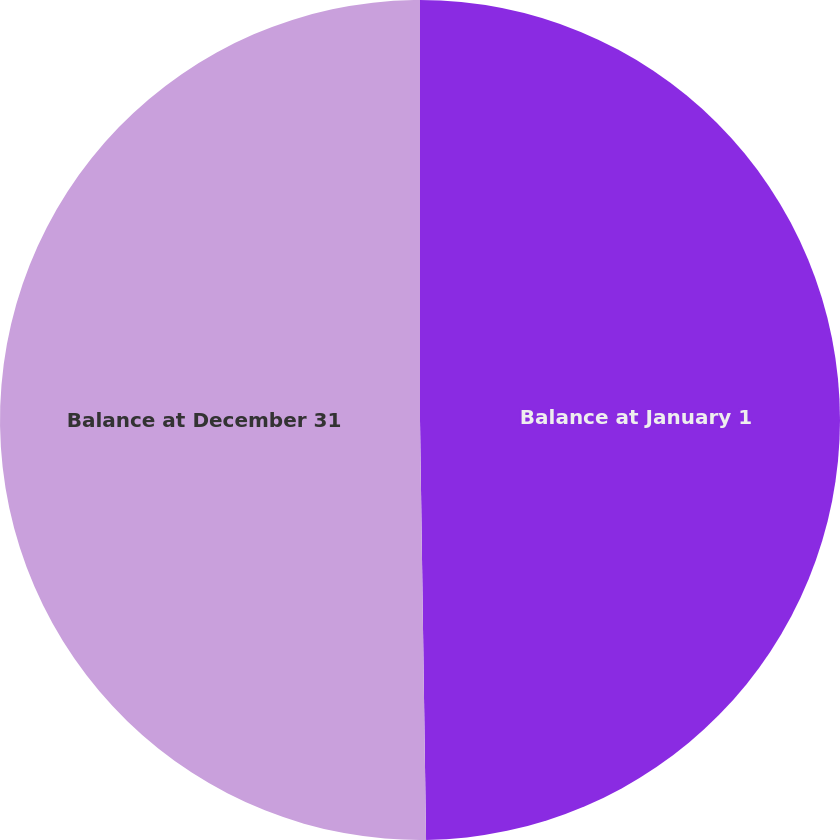<chart> <loc_0><loc_0><loc_500><loc_500><pie_chart><fcel>Balance at January 1<fcel>Balance at December 31<nl><fcel>49.77%<fcel>50.23%<nl></chart> 